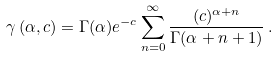<formula> <loc_0><loc_0><loc_500><loc_500>\gamma \left ( \alpha , c \right ) = \Gamma ( \alpha ) e ^ { - c } \sum _ { n = 0 } ^ { \infty } \frac { ( c ) ^ { \alpha + n } } { \Gamma ( \alpha + n + 1 ) } \, .</formula> 